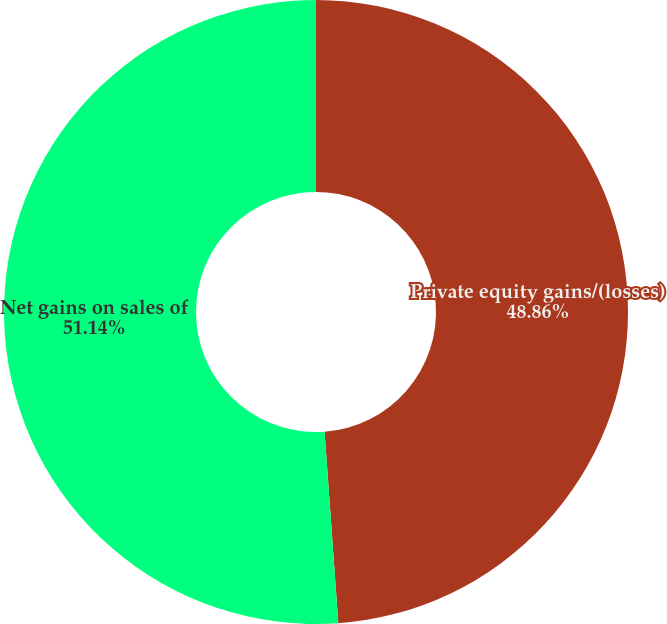Convert chart to OTSL. <chart><loc_0><loc_0><loc_500><loc_500><pie_chart><fcel>Private equity gains/(losses)<fcel>Net gains on sales of<nl><fcel>48.86%<fcel>51.14%<nl></chart> 